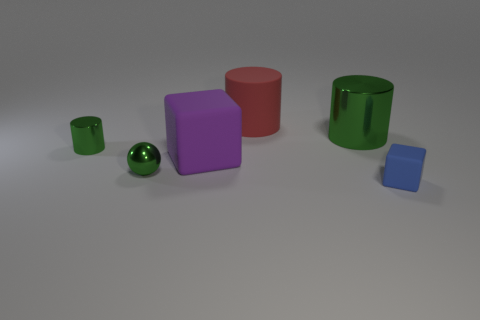Subtract all green shiny cylinders. How many cylinders are left? 1 Add 1 tiny green metallic balls. How many objects exist? 7 Subtract 1 blocks. How many blocks are left? 1 Subtract all red cylinders. How many cylinders are left? 2 Subtract 0 blue cylinders. How many objects are left? 6 Subtract all blocks. How many objects are left? 4 Subtract all brown cylinders. Subtract all purple balls. How many cylinders are left? 3 Subtract all purple spheres. How many green blocks are left? 0 Subtract all small blue blocks. Subtract all small blue matte objects. How many objects are left? 4 Add 3 large cylinders. How many large cylinders are left? 5 